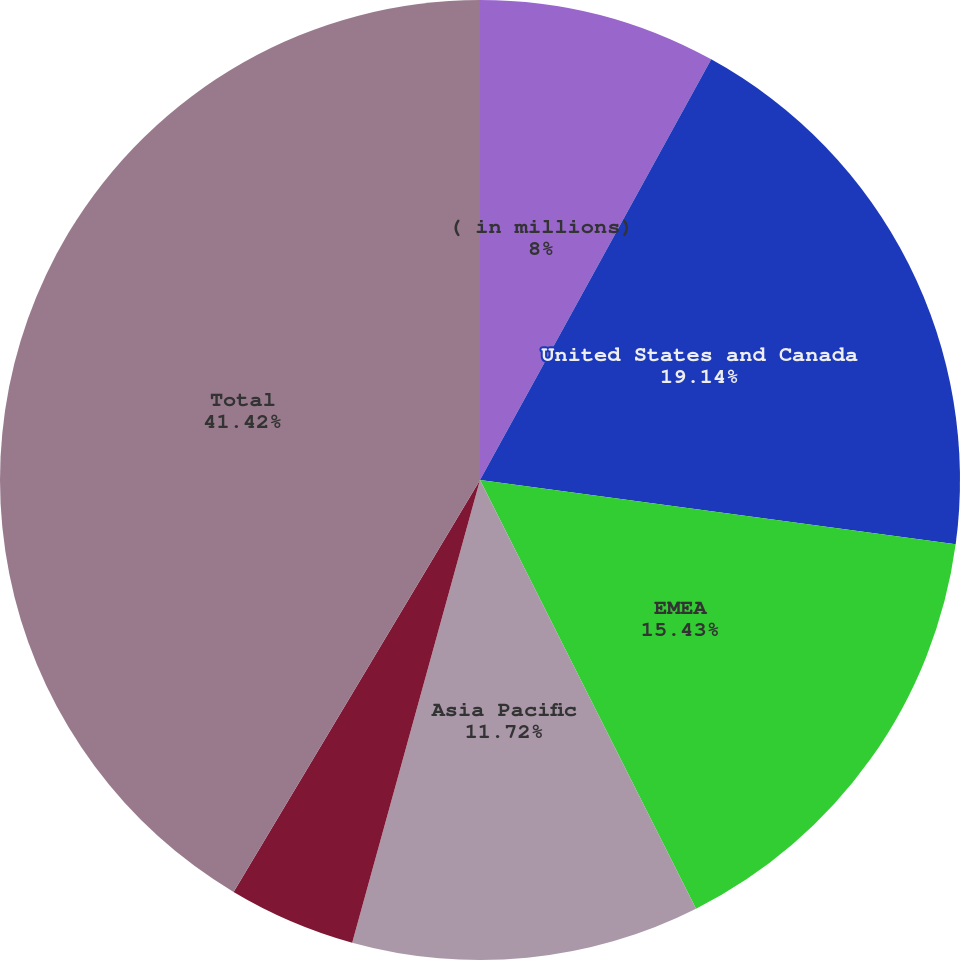<chart> <loc_0><loc_0><loc_500><loc_500><pie_chart><fcel>( in millions)<fcel>United States and Canada<fcel>EMEA<fcel>Asia Pacific<fcel>Latin America<fcel>Total<nl><fcel>8.0%<fcel>19.14%<fcel>15.43%<fcel>11.72%<fcel>4.29%<fcel>41.42%<nl></chart> 